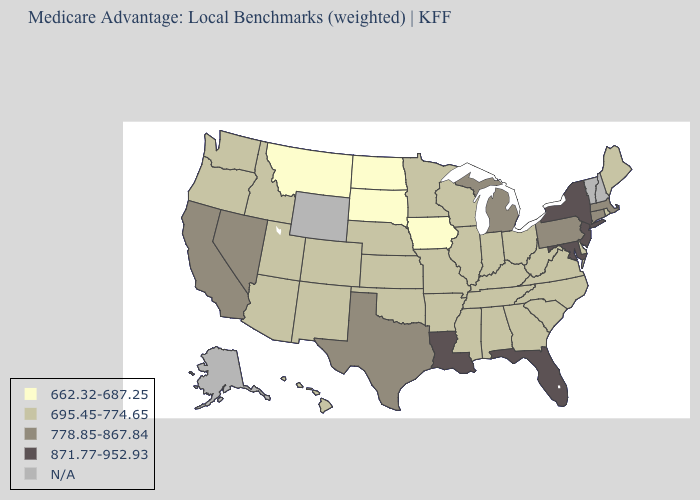Among the states that border Mississippi , which have the lowest value?
Write a very short answer. Alabama, Arkansas, Tennessee. What is the highest value in the USA?
Keep it brief. 871.77-952.93. What is the value of Kansas?
Give a very brief answer. 695.45-774.65. Does the first symbol in the legend represent the smallest category?
Be succinct. Yes. Name the states that have a value in the range N/A?
Keep it brief. Alaska, New Hampshire, Vermont, Wyoming. Name the states that have a value in the range N/A?
Concise answer only. Alaska, New Hampshire, Vermont, Wyoming. Name the states that have a value in the range 695.45-774.65?
Short answer required. Alabama, Arkansas, Arizona, Colorado, Delaware, Georgia, Hawaii, Idaho, Illinois, Indiana, Kansas, Kentucky, Maine, Minnesota, Missouri, Mississippi, North Carolina, Nebraska, New Mexico, Ohio, Oklahoma, Oregon, Rhode Island, South Carolina, Tennessee, Utah, Virginia, Washington, Wisconsin, West Virginia. What is the value of California?
Answer briefly. 778.85-867.84. Name the states that have a value in the range N/A?
Give a very brief answer. Alaska, New Hampshire, Vermont, Wyoming. Which states have the lowest value in the West?
Answer briefly. Montana. Name the states that have a value in the range 778.85-867.84?
Quick response, please. California, Connecticut, Massachusetts, Michigan, Nevada, Pennsylvania, Texas. Does Nebraska have the lowest value in the MidWest?
Be succinct. No. Does the map have missing data?
Quick response, please. Yes. 